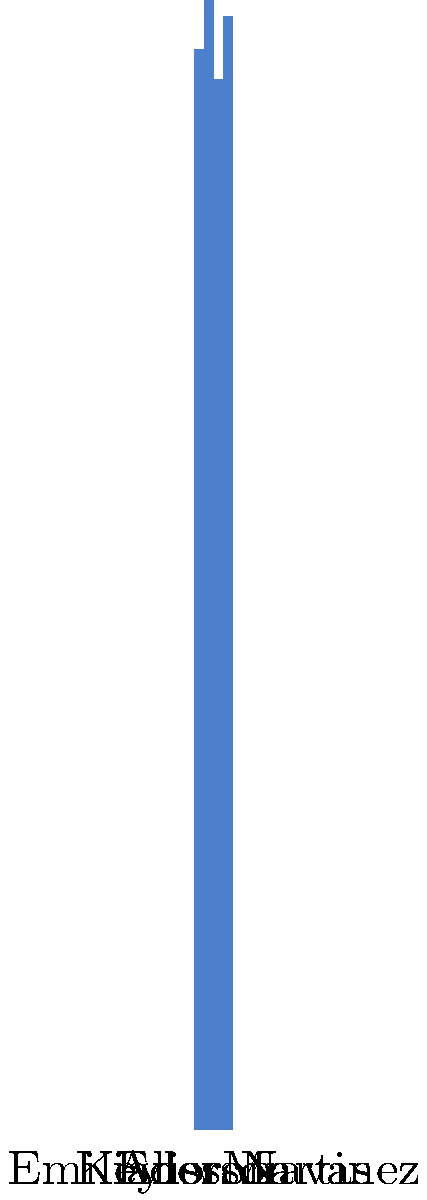Based on the infographic showing save percentages of Latin American goalkeepers in European leagues, which goalkeeper has the highest save percentage, and what is the difference between his performance and that of the goalkeeper with the lowest save percentage? To answer this question, we need to follow these steps:

1. Identify the goalkeeper with the highest save percentage:
   - Alisson: 78.5%
   - Ederson: 82.1%
   - Emiliano Martinez: 76.3%
   - Keylor Navas: 80.9%

   Ederson has the highest save percentage at 82.1%.

2. Identify the goalkeeper with the lowest save percentage:
   Emiliano Martinez has the lowest save percentage at 76.3%.

3. Calculate the difference between the highest and lowest save percentages:
   $82.1\% - 76.3\% = 5.8\%$

Therefore, Ederson has the highest save percentage, and the difference between his performance and that of Emiliano Martinez (the goalkeeper with the lowest save percentage) is 5.8 percentage points.
Answer: Ederson; 5.8 percentage points 